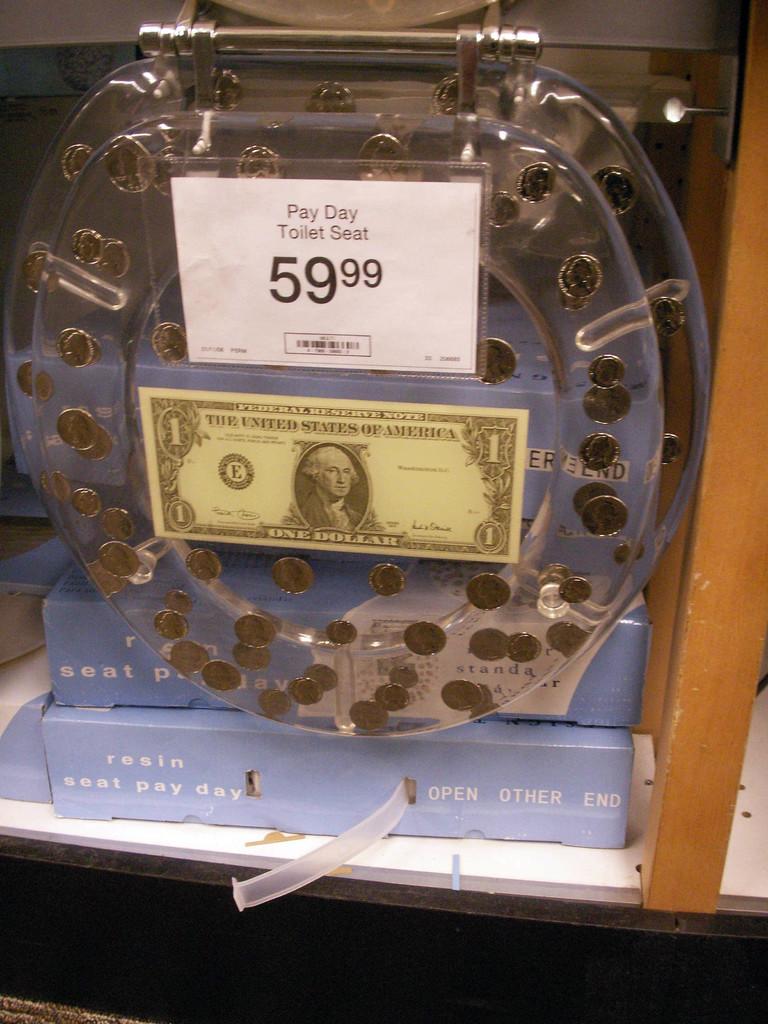How much does this toilet seat cost?
Give a very brief answer. 59.99. Is pay day the name brand of this toilet seat?
Give a very brief answer. Yes. 